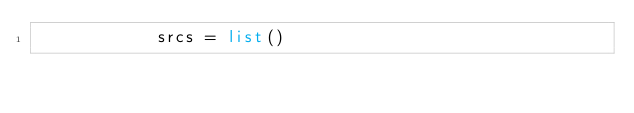Convert code to text. <code><loc_0><loc_0><loc_500><loc_500><_Python_>            srcs = list()</code> 